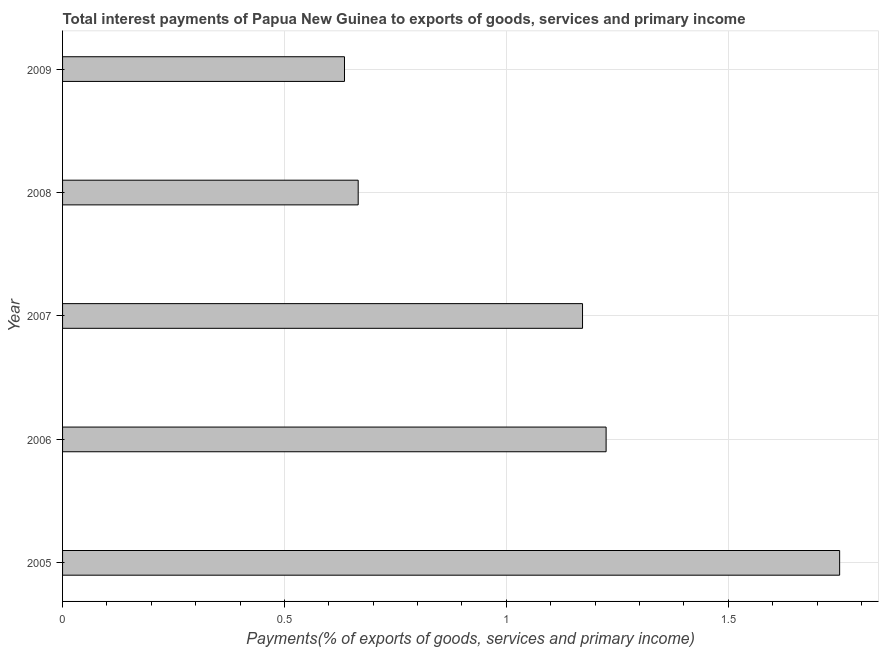Does the graph contain any zero values?
Make the answer very short. No. What is the title of the graph?
Give a very brief answer. Total interest payments of Papua New Guinea to exports of goods, services and primary income. What is the label or title of the X-axis?
Offer a very short reply. Payments(% of exports of goods, services and primary income). What is the total interest payments on external debt in 2009?
Ensure brevity in your answer.  0.64. Across all years, what is the maximum total interest payments on external debt?
Provide a short and direct response. 1.75. Across all years, what is the minimum total interest payments on external debt?
Your answer should be compact. 0.64. In which year was the total interest payments on external debt minimum?
Your answer should be very brief. 2009. What is the sum of the total interest payments on external debt?
Your answer should be very brief. 5.45. What is the difference between the total interest payments on external debt in 2008 and 2009?
Your answer should be very brief. 0.03. What is the average total interest payments on external debt per year?
Give a very brief answer. 1.09. What is the median total interest payments on external debt?
Provide a succinct answer. 1.17. What is the ratio of the total interest payments on external debt in 2005 to that in 2006?
Provide a succinct answer. 1.43. What is the difference between the highest and the second highest total interest payments on external debt?
Provide a succinct answer. 0.53. What is the difference between the highest and the lowest total interest payments on external debt?
Give a very brief answer. 1.12. In how many years, is the total interest payments on external debt greater than the average total interest payments on external debt taken over all years?
Keep it short and to the point. 3. Are all the bars in the graph horizontal?
Give a very brief answer. Yes. How many years are there in the graph?
Provide a short and direct response. 5. What is the difference between two consecutive major ticks on the X-axis?
Keep it short and to the point. 0.5. What is the Payments(% of exports of goods, services and primary income) in 2005?
Make the answer very short. 1.75. What is the Payments(% of exports of goods, services and primary income) of 2006?
Provide a short and direct response. 1.22. What is the Payments(% of exports of goods, services and primary income) of 2007?
Offer a very short reply. 1.17. What is the Payments(% of exports of goods, services and primary income) in 2008?
Your answer should be very brief. 0.67. What is the Payments(% of exports of goods, services and primary income) of 2009?
Your response must be concise. 0.64. What is the difference between the Payments(% of exports of goods, services and primary income) in 2005 and 2006?
Offer a very short reply. 0.53. What is the difference between the Payments(% of exports of goods, services and primary income) in 2005 and 2007?
Provide a short and direct response. 0.58. What is the difference between the Payments(% of exports of goods, services and primary income) in 2005 and 2008?
Provide a succinct answer. 1.08. What is the difference between the Payments(% of exports of goods, services and primary income) in 2005 and 2009?
Offer a terse response. 1.12. What is the difference between the Payments(% of exports of goods, services and primary income) in 2006 and 2007?
Provide a short and direct response. 0.05. What is the difference between the Payments(% of exports of goods, services and primary income) in 2006 and 2008?
Provide a short and direct response. 0.56. What is the difference between the Payments(% of exports of goods, services and primary income) in 2006 and 2009?
Keep it short and to the point. 0.59. What is the difference between the Payments(% of exports of goods, services and primary income) in 2007 and 2008?
Offer a very short reply. 0.51. What is the difference between the Payments(% of exports of goods, services and primary income) in 2007 and 2009?
Your response must be concise. 0.54. What is the difference between the Payments(% of exports of goods, services and primary income) in 2008 and 2009?
Your answer should be compact. 0.03. What is the ratio of the Payments(% of exports of goods, services and primary income) in 2005 to that in 2006?
Ensure brevity in your answer.  1.43. What is the ratio of the Payments(% of exports of goods, services and primary income) in 2005 to that in 2007?
Offer a very short reply. 1.49. What is the ratio of the Payments(% of exports of goods, services and primary income) in 2005 to that in 2008?
Provide a succinct answer. 2.63. What is the ratio of the Payments(% of exports of goods, services and primary income) in 2005 to that in 2009?
Your answer should be very brief. 2.76. What is the ratio of the Payments(% of exports of goods, services and primary income) in 2006 to that in 2007?
Give a very brief answer. 1.04. What is the ratio of the Payments(% of exports of goods, services and primary income) in 2006 to that in 2008?
Provide a succinct answer. 1.84. What is the ratio of the Payments(% of exports of goods, services and primary income) in 2006 to that in 2009?
Offer a terse response. 1.93. What is the ratio of the Payments(% of exports of goods, services and primary income) in 2007 to that in 2008?
Your answer should be very brief. 1.76. What is the ratio of the Payments(% of exports of goods, services and primary income) in 2007 to that in 2009?
Provide a short and direct response. 1.84. What is the ratio of the Payments(% of exports of goods, services and primary income) in 2008 to that in 2009?
Offer a terse response. 1.05. 